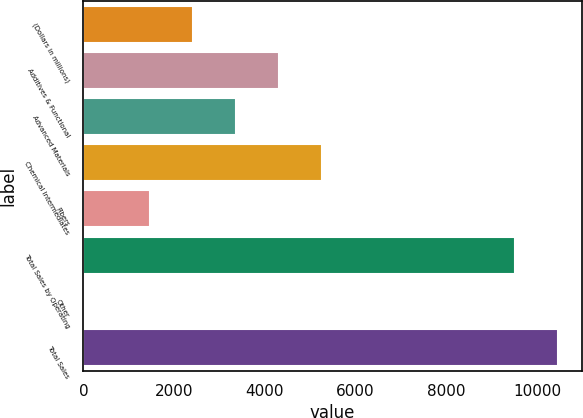<chart> <loc_0><loc_0><loc_500><loc_500><bar_chart><fcel>(Dollars in millions)<fcel>Additives & Functional<fcel>Advanced Materials<fcel>Chemical Intermediates<fcel>Fibers<fcel>Total Sales by Operating<fcel>Other<fcel>Total Sales<nl><fcel>2407.9<fcel>4309.7<fcel>3358.8<fcel>5260.6<fcel>1457<fcel>9509<fcel>18<fcel>10459.9<nl></chart> 